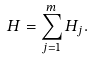Convert formula to latex. <formula><loc_0><loc_0><loc_500><loc_500>H = \sum _ { j = 1 } ^ { m } H _ { j } .</formula> 